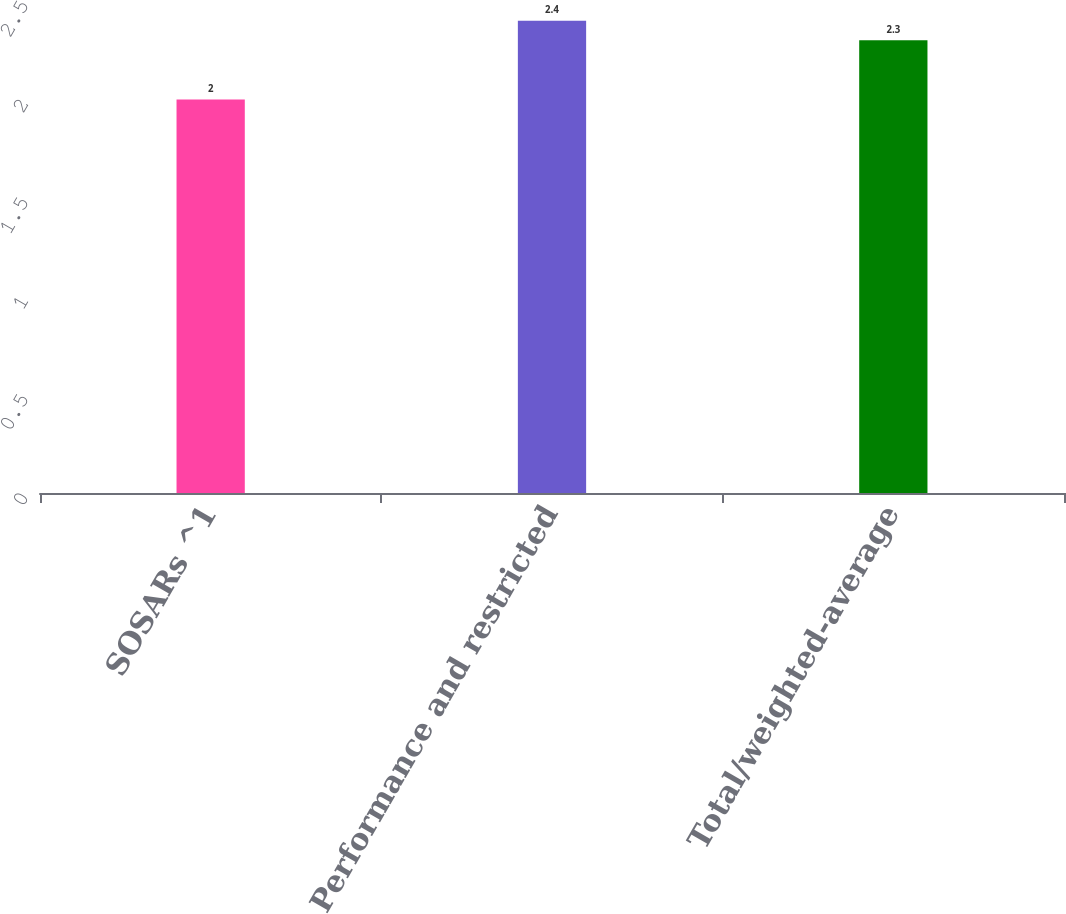Convert chart. <chart><loc_0><loc_0><loc_500><loc_500><bar_chart><fcel>SOSARs ^1<fcel>Performance and restricted<fcel>Total/weighted-average<nl><fcel>2<fcel>2.4<fcel>2.3<nl></chart> 